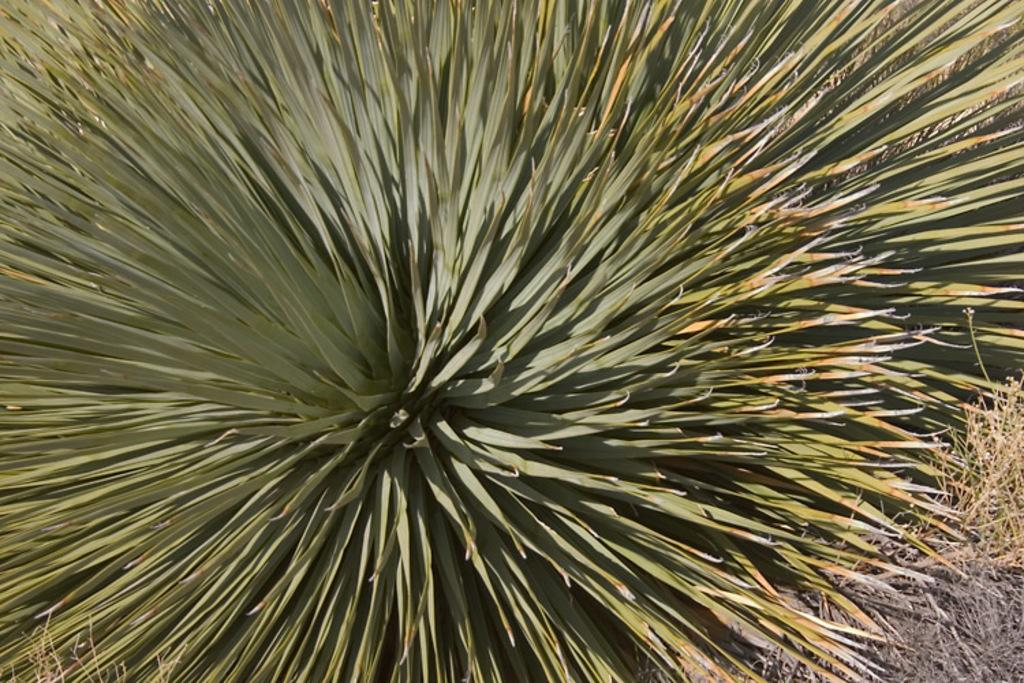What is the main subject in the center of the image? There is a plant in the center of the image. What type of straw is the man using to protect himself from the weather in the image? There is no man or straw present in the image; it only features a plant. 